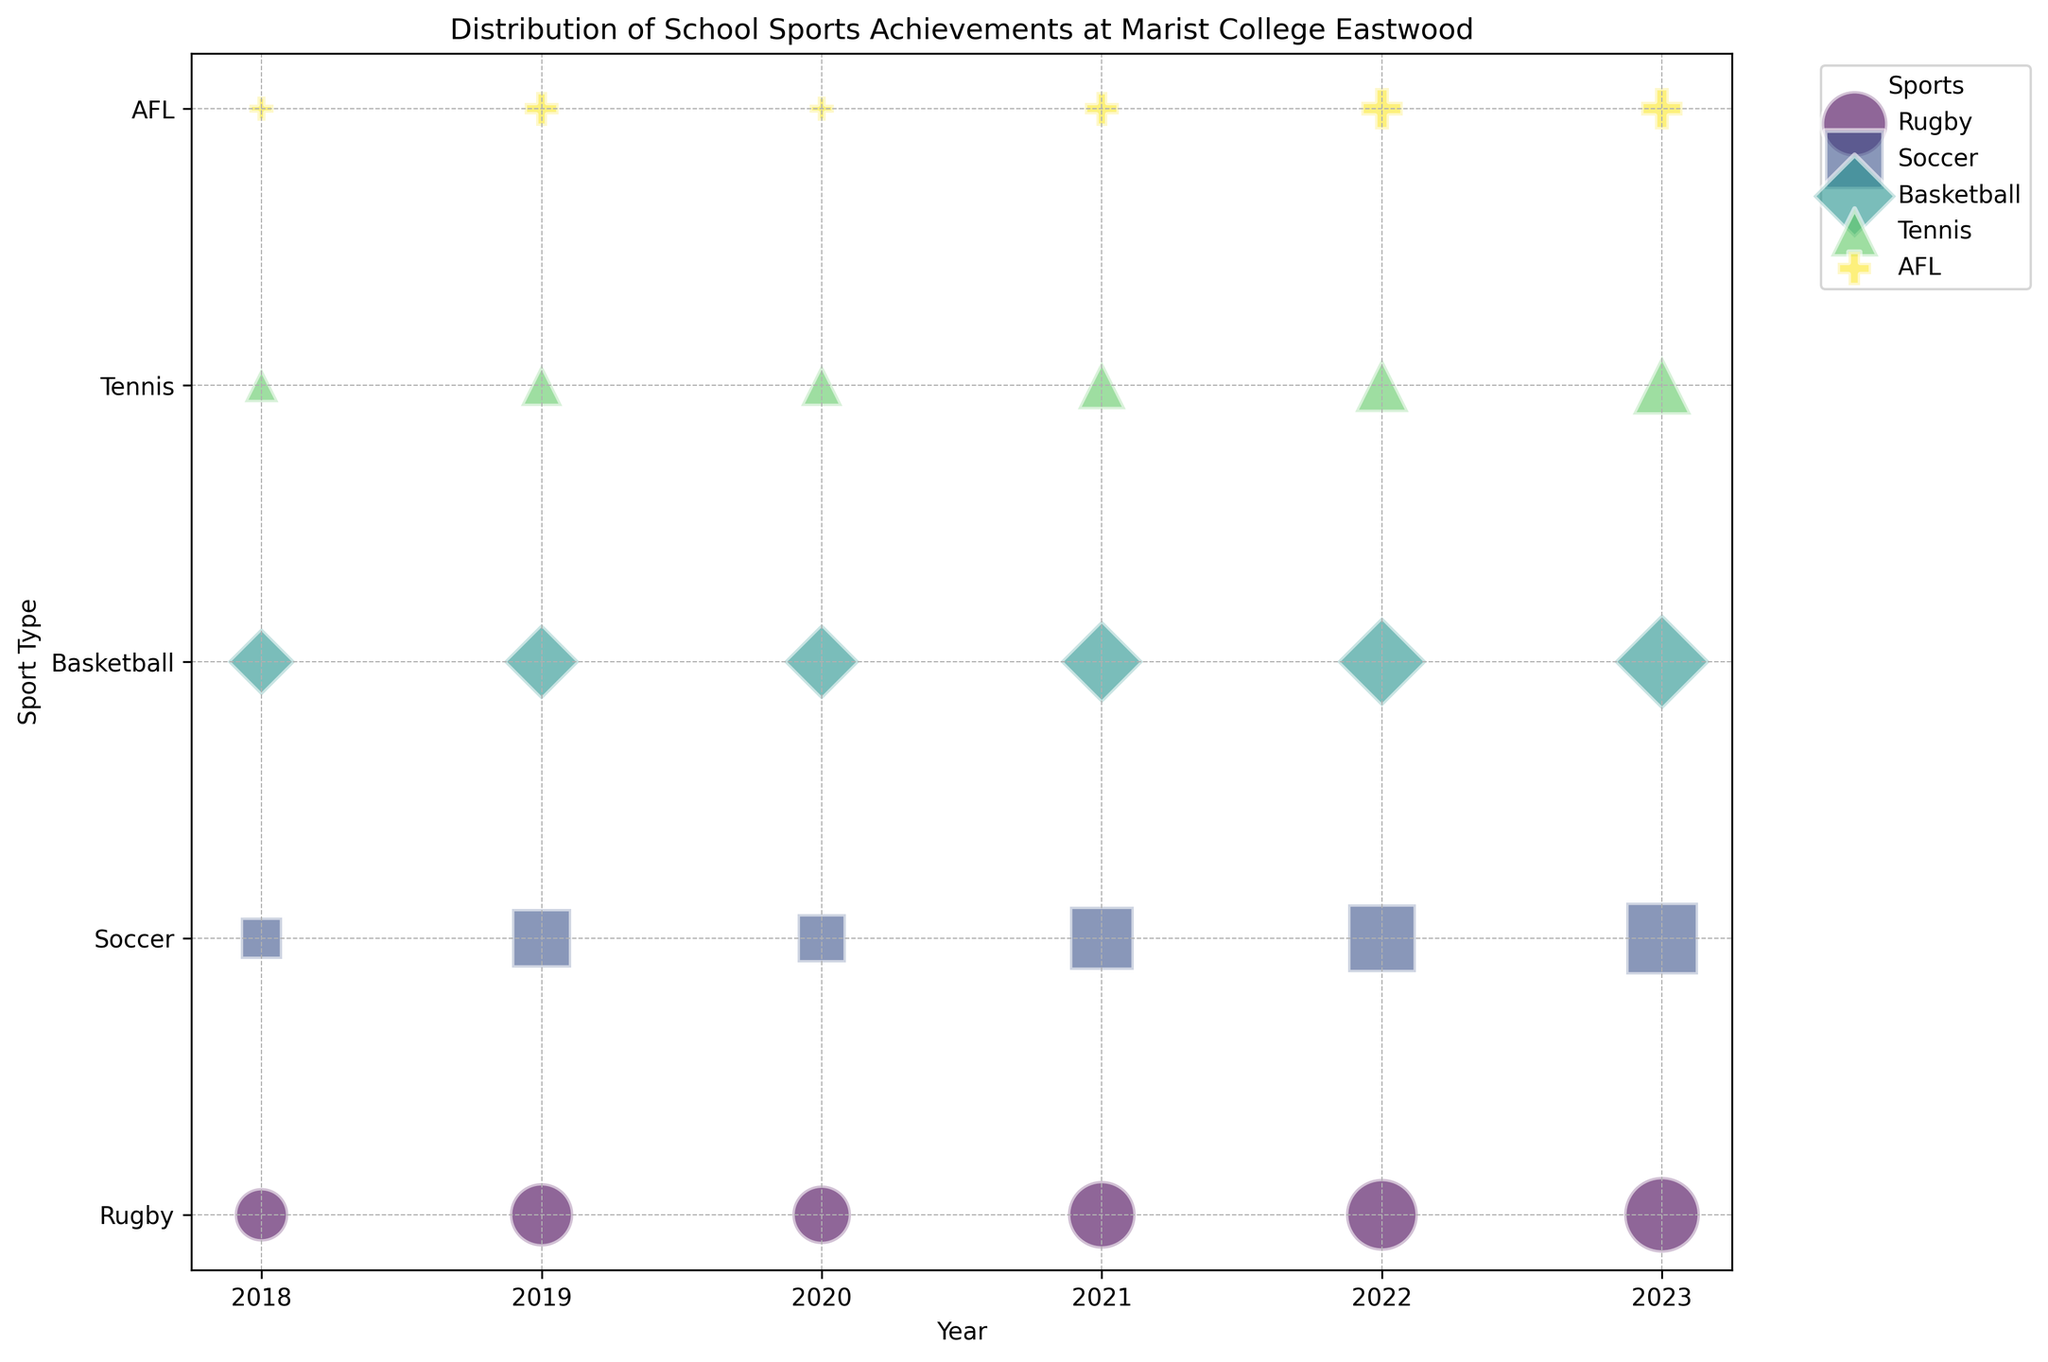Which sport had the highest number of achievements in 2023? To determine the sport with the highest achievements in 2023, look at the year 2023 and compare the size of the bubbles. The largest bubble indicates the highest number of achievements.
Answer: Rugby How many total achievements were recorded for Basketball between 2018 and 2023? Sum the achievements for Basketball from each year. The values are: 2018 (4), 2019 (5), 2020 (5), 2021 (6), 2022 (7), and 2023 (8). 4 + 5 + 5 + 6 + 7 + 8 = 35.
Answer: 35 Which year had the highest number of achievements across all sports? To identify the year with the highest cumulative achievements, sum the achievements for each sport in each year and compare. The sums are: 2018 (15), 2019 (23), 2020 (19), 2021 (27), 2022 (32), and 2023 (36). The highest is 2023.
Answer: 2023 Did Tennis see an increase or decrease in achievements from 2018 to 2023? Compare the number of achievements for Tennis in 2018 (2) and 2023 (6). Since 6 is greater than 2, there was an increase.
Answer: Increase What is the average number of achievements for Soccer across all years? Sum the achievements for Soccer (3 + 6 + 4 + 7 + 8 + 9 = 37) and divide by the number of years (6). 37 / 6 ≈ 6.17.
Answer: 6.17 Was there any year where AFL had the same number of achievements as the previous year? Compare the number of achievements for AFL year by year: 2018 (1), 2019 (2), 2020 (1), 2021 (2), 2022 (3), 2023 (3). 2022 and 2023 both had 3 achievements.
Answer: Yes How many more Rugby achievements were there in 2023 compared to 2018? Subtract the 2018 Rugby achievements (5) from the 2023 Rugby achievements (10). 10 - 5 = 5.
Answer: 5 Which sport had the least achievements in 2020? Compare the sizes of the bubbles for each sport in 2020. The smallest bubble corresponds to AFL with 1 achievement.
Answer: AFL 